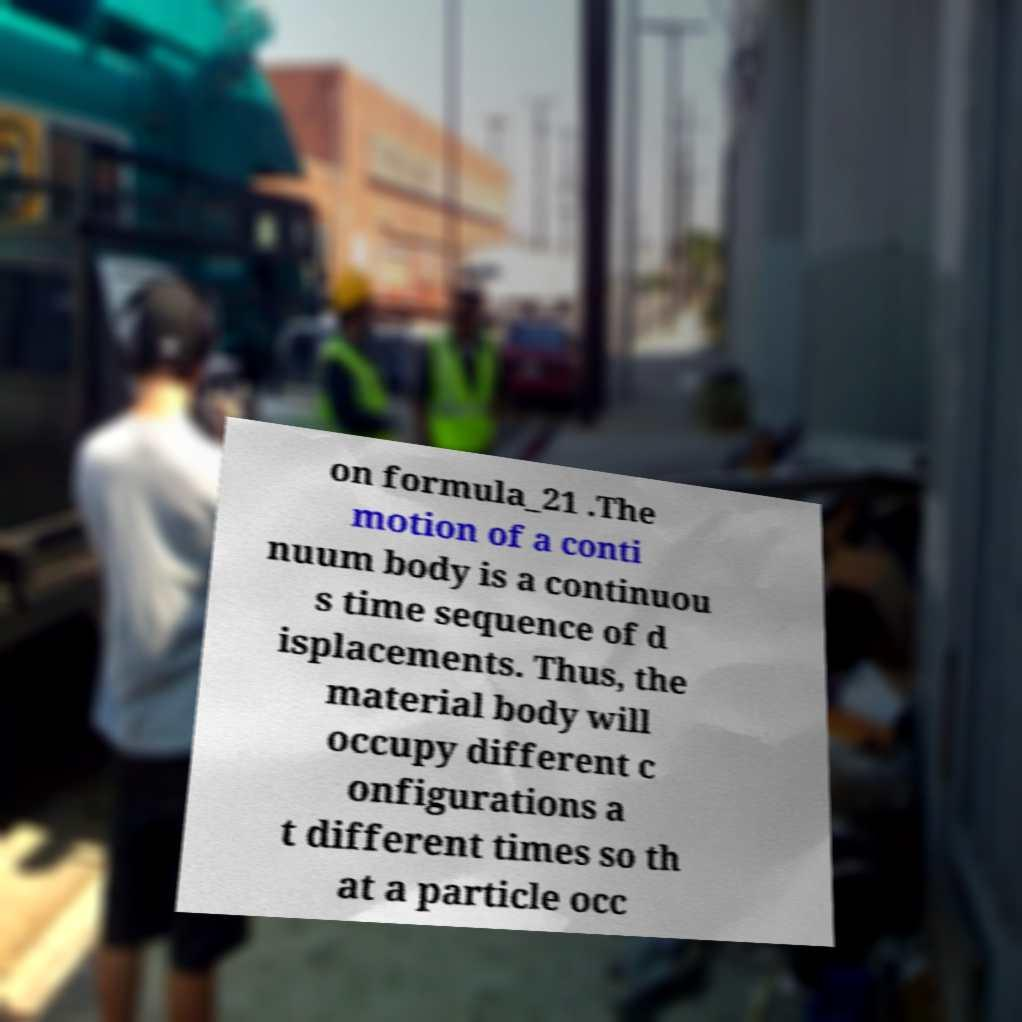Can you read and provide the text displayed in the image?This photo seems to have some interesting text. Can you extract and type it out for me? on formula_21 .The motion of a conti nuum body is a continuou s time sequence of d isplacements. Thus, the material body will occupy different c onfigurations a t different times so th at a particle occ 